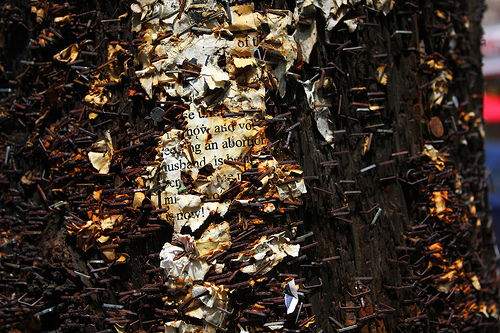<image>
Is the nail above the tree? No. The nail is not positioned above the tree. The vertical arrangement shows a different relationship. 